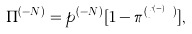<formula> <loc_0><loc_0><loc_500><loc_500>\Pi ^ { ( - N ) } = p ^ { ( - N ) } [ 1 - \pi ^ { ( j ^ { ( - N ) } ) } ] ,</formula> 